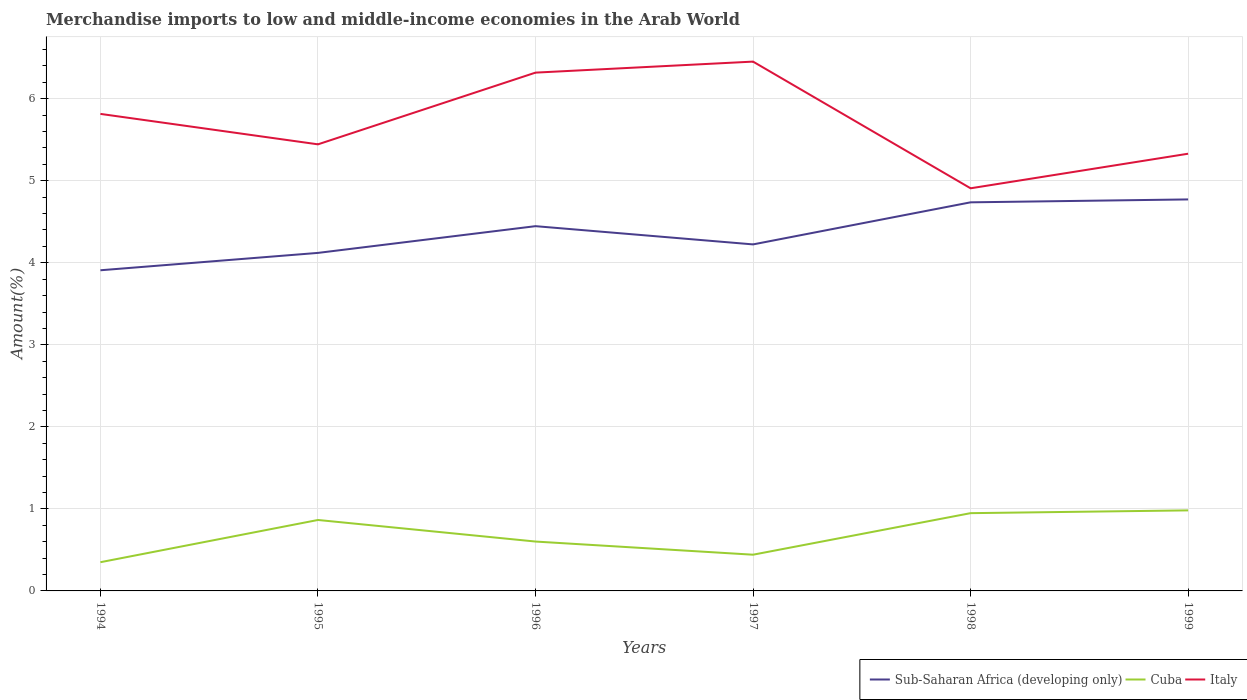How many different coloured lines are there?
Your answer should be very brief. 3. Is the number of lines equal to the number of legend labels?
Provide a short and direct response. Yes. Across all years, what is the maximum percentage of amount earned from merchandise imports in Italy?
Your answer should be very brief. 4.91. What is the total percentage of amount earned from merchandise imports in Italy in the graph?
Provide a short and direct response. -0.64. What is the difference between the highest and the second highest percentage of amount earned from merchandise imports in Sub-Saharan Africa (developing only)?
Your answer should be compact. 0.86. How many years are there in the graph?
Ensure brevity in your answer.  6. What is the difference between two consecutive major ticks on the Y-axis?
Offer a very short reply. 1. Are the values on the major ticks of Y-axis written in scientific E-notation?
Keep it short and to the point. No. Does the graph contain any zero values?
Provide a short and direct response. No. Where does the legend appear in the graph?
Provide a short and direct response. Bottom right. How many legend labels are there?
Your answer should be very brief. 3. How are the legend labels stacked?
Ensure brevity in your answer.  Horizontal. What is the title of the graph?
Ensure brevity in your answer.  Merchandise imports to low and middle-income economies in the Arab World. What is the label or title of the Y-axis?
Your answer should be very brief. Amount(%). What is the Amount(%) of Sub-Saharan Africa (developing only) in 1994?
Give a very brief answer. 3.91. What is the Amount(%) of Cuba in 1994?
Your answer should be very brief. 0.35. What is the Amount(%) in Italy in 1994?
Make the answer very short. 5.82. What is the Amount(%) of Sub-Saharan Africa (developing only) in 1995?
Your answer should be compact. 4.12. What is the Amount(%) of Cuba in 1995?
Make the answer very short. 0.86. What is the Amount(%) in Italy in 1995?
Offer a terse response. 5.44. What is the Amount(%) in Sub-Saharan Africa (developing only) in 1996?
Offer a very short reply. 4.45. What is the Amount(%) of Cuba in 1996?
Provide a succinct answer. 0.6. What is the Amount(%) in Italy in 1996?
Give a very brief answer. 6.32. What is the Amount(%) in Sub-Saharan Africa (developing only) in 1997?
Provide a succinct answer. 4.22. What is the Amount(%) of Cuba in 1997?
Your answer should be very brief. 0.44. What is the Amount(%) in Italy in 1997?
Give a very brief answer. 6.45. What is the Amount(%) in Sub-Saharan Africa (developing only) in 1998?
Your answer should be compact. 4.74. What is the Amount(%) of Cuba in 1998?
Make the answer very short. 0.95. What is the Amount(%) in Italy in 1998?
Offer a very short reply. 4.91. What is the Amount(%) in Sub-Saharan Africa (developing only) in 1999?
Keep it short and to the point. 4.77. What is the Amount(%) of Cuba in 1999?
Give a very brief answer. 0.98. What is the Amount(%) of Italy in 1999?
Provide a short and direct response. 5.33. Across all years, what is the maximum Amount(%) in Sub-Saharan Africa (developing only)?
Ensure brevity in your answer.  4.77. Across all years, what is the maximum Amount(%) of Cuba?
Your answer should be compact. 0.98. Across all years, what is the maximum Amount(%) in Italy?
Your answer should be compact. 6.45. Across all years, what is the minimum Amount(%) of Sub-Saharan Africa (developing only)?
Make the answer very short. 3.91. Across all years, what is the minimum Amount(%) in Cuba?
Your answer should be very brief. 0.35. Across all years, what is the minimum Amount(%) in Italy?
Provide a succinct answer. 4.91. What is the total Amount(%) in Sub-Saharan Africa (developing only) in the graph?
Your response must be concise. 26.21. What is the total Amount(%) in Cuba in the graph?
Your answer should be compact. 4.19. What is the total Amount(%) in Italy in the graph?
Your response must be concise. 34.27. What is the difference between the Amount(%) of Sub-Saharan Africa (developing only) in 1994 and that in 1995?
Give a very brief answer. -0.21. What is the difference between the Amount(%) in Cuba in 1994 and that in 1995?
Your response must be concise. -0.51. What is the difference between the Amount(%) of Italy in 1994 and that in 1995?
Your response must be concise. 0.37. What is the difference between the Amount(%) of Sub-Saharan Africa (developing only) in 1994 and that in 1996?
Your answer should be very brief. -0.54. What is the difference between the Amount(%) in Cuba in 1994 and that in 1996?
Give a very brief answer. -0.25. What is the difference between the Amount(%) of Italy in 1994 and that in 1996?
Ensure brevity in your answer.  -0.5. What is the difference between the Amount(%) of Sub-Saharan Africa (developing only) in 1994 and that in 1997?
Offer a very short reply. -0.32. What is the difference between the Amount(%) in Cuba in 1994 and that in 1997?
Offer a very short reply. -0.09. What is the difference between the Amount(%) in Italy in 1994 and that in 1997?
Keep it short and to the point. -0.64. What is the difference between the Amount(%) in Sub-Saharan Africa (developing only) in 1994 and that in 1998?
Give a very brief answer. -0.83. What is the difference between the Amount(%) in Cuba in 1994 and that in 1998?
Offer a very short reply. -0.6. What is the difference between the Amount(%) of Italy in 1994 and that in 1998?
Your answer should be compact. 0.91. What is the difference between the Amount(%) in Sub-Saharan Africa (developing only) in 1994 and that in 1999?
Keep it short and to the point. -0.86. What is the difference between the Amount(%) in Cuba in 1994 and that in 1999?
Make the answer very short. -0.63. What is the difference between the Amount(%) in Italy in 1994 and that in 1999?
Offer a terse response. 0.49. What is the difference between the Amount(%) in Sub-Saharan Africa (developing only) in 1995 and that in 1996?
Provide a short and direct response. -0.33. What is the difference between the Amount(%) of Cuba in 1995 and that in 1996?
Make the answer very short. 0.26. What is the difference between the Amount(%) of Italy in 1995 and that in 1996?
Provide a short and direct response. -0.87. What is the difference between the Amount(%) in Sub-Saharan Africa (developing only) in 1995 and that in 1997?
Make the answer very short. -0.1. What is the difference between the Amount(%) in Cuba in 1995 and that in 1997?
Make the answer very short. 0.42. What is the difference between the Amount(%) of Italy in 1995 and that in 1997?
Give a very brief answer. -1.01. What is the difference between the Amount(%) in Sub-Saharan Africa (developing only) in 1995 and that in 1998?
Ensure brevity in your answer.  -0.62. What is the difference between the Amount(%) in Cuba in 1995 and that in 1998?
Your answer should be very brief. -0.08. What is the difference between the Amount(%) in Italy in 1995 and that in 1998?
Your answer should be very brief. 0.54. What is the difference between the Amount(%) of Sub-Saharan Africa (developing only) in 1995 and that in 1999?
Offer a very short reply. -0.65. What is the difference between the Amount(%) in Cuba in 1995 and that in 1999?
Your response must be concise. -0.12. What is the difference between the Amount(%) of Italy in 1995 and that in 1999?
Offer a terse response. 0.11. What is the difference between the Amount(%) in Sub-Saharan Africa (developing only) in 1996 and that in 1997?
Provide a succinct answer. 0.22. What is the difference between the Amount(%) in Cuba in 1996 and that in 1997?
Offer a very short reply. 0.16. What is the difference between the Amount(%) in Italy in 1996 and that in 1997?
Your answer should be very brief. -0.13. What is the difference between the Amount(%) in Sub-Saharan Africa (developing only) in 1996 and that in 1998?
Make the answer very short. -0.29. What is the difference between the Amount(%) in Cuba in 1996 and that in 1998?
Give a very brief answer. -0.35. What is the difference between the Amount(%) in Italy in 1996 and that in 1998?
Keep it short and to the point. 1.41. What is the difference between the Amount(%) in Sub-Saharan Africa (developing only) in 1996 and that in 1999?
Your answer should be compact. -0.33. What is the difference between the Amount(%) of Cuba in 1996 and that in 1999?
Your answer should be very brief. -0.38. What is the difference between the Amount(%) in Sub-Saharan Africa (developing only) in 1997 and that in 1998?
Provide a short and direct response. -0.51. What is the difference between the Amount(%) in Cuba in 1997 and that in 1998?
Provide a succinct answer. -0.51. What is the difference between the Amount(%) of Italy in 1997 and that in 1998?
Keep it short and to the point. 1.54. What is the difference between the Amount(%) of Sub-Saharan Africa (developing only) in 1997 and that in 1999?
Your answer should be very brief. -0.55. What is the difference between the Amount(%) in Cuba in 1997 and that in 1999?
Offer a terse response. -0.54. What is the difference between the Amount(%) of Italy in 1997 and that in 1999?
Provide a short and direct response. 1.12. What is the difference between the Amount(%) of Sub-Saharan Africa (developing only) in 1998 and that in 1999?
Keep it short and to the point. -0.04. What is the difference between the Amount(%) of Cuba in 1998 and that in 1999?
Provide a short and direct response. -0.03. What is the difference between the Amount(%) in Italy in 1998 and that in 1999?
Your answer should be very brief. -0.42. What is the difference between the Amount(%) in Sub-Saharan Africa (developing only) in 1994 and the Amount(%) in Cuba in 1995?
Keep it short and to the point. 3.04. What is the difference between the Amount(%) in Sub-Saharan Africa (developing only) in 1994 and the Amount(%) in Italy in 1995?
Your answer should be very brief. -1.54. What is the difference between the Amount(%) of Cuba in 1994 and the Amount(%) of Italy in 1995?
Offer a very short reply. -5.09. What is the difference between the Amount(%) in Sub-Saharan Africa (developing only) in 1994 and the Amount(%) in Cuba in 1996?
Offer a terse response. 3.31. What is the difference between the Amount(%) in Sub-Saharan Africa (developing only) in 1994 and the Amount(%) in Italy in 1996?
Provide a succinct answer. -2.41. What is the difference between the Amount(%) in Cuba in 1994 and the Amount(%) in Italy in 1996?
Provide a succinct answer. -5.97. What is the difference between the Amount(%) of Sub-Saharan Africa (developing only) in 1994 and the Amount(%) of Cuba in 1997?
Provide a short and direct response. 3.47. What is the difference between the Amount(%) in Sub-Saharan Africa (developing only) in 1994 and the Amount(%) in Italy in 1997?
Give a very brief answer. -2.54. What is the difference between the Amount(%) of Cuba in 1994 and the Amount(%) of Italy in 1997?
Ensure brevity in your answer.  -6.1. What is the difference between the Amount(%) of Sub-Saharan Africa (developing only) in 1994 and the Amount(%) of Cuba in 1998?
Your answer should be compact. 2.96. What is the difference between the Amount(%) in Sub-Saharan Africa (developing only) in 1994 and the Amount(%) in Italy in 1998?
Offer a very short reply. -1. What is the difference between the Amount(%) in Cuba in 1994 and the Amount(%) in Italy in 1998?
Ensure brevity in your answer.  -4.56. What is the difference between the Amount(%) of Sub-Saharan Africa (developing only) in 1994 and the Amount(%) of Cuba in 1999?
Ensure brevity in your answer.  2.93. What is the difference between the Amount(%) of Sub-Saharan Africa (developing only) in 1994 and the Amount(%) of Italy in 1999?
Offer a terse response. -1.42. What is the difference between the Amount(%) in Cuba in 1994 and the Amount(%) in Italy in 1999?
Provide a succinct answer. -4.98. What is the difference between the Amount(%) of Sub-Saharan Africa (developing only) in 1995 and the Amount(%) of Cuba in 1996?
Your answer should be very brief. 3.52. What is the difference between the Amount(%) in Sub-Saharan Africa (developing only) in 1995 and the Amount(%) in Italy in 1996?
Your response must be concise. -2.2. What is the difference between the Amount(%) in Cuba in 1995 and the Amount(%) in Italy in 1996?
Your response must be concise. -5.45. What is the difference between the Amount(%) in Sub-Saharan Africa (developing only) in 1995 and the Amount(%) in Cuba in 1997?
Your answer should be very brief. 3.68. What is the difference between the Amount(%) in Sub-Saharan Africa (developing only) in 1995 and the Amount(%) in Italy in 1997?
Provide a short and direct response. -2.33. What is the difference between the Amount(%) in Cuba in 1995 and the Amount(%) in Italy in 1997?
Offer a terse response. -5.59. What is the difference between the Amount(%) of Sub-Saharan Africa (developing only) in 1995 and the Amount(%) of Cuba in 1998?
Provide a succinct answer. 3.17. What is the difference between the Amount(%) of Sub-Saharan Africa (developing only) in 1995 and the Amount(%) of Italy in 1998?
Give a very brief answer. -0.79. What is the difference between the Amount(%) in Cuba in 1995 and the Amount(%) in Italy in 1998?
Your answer should be very brief. -4.04. What is the difference between the Amount(%) of Sub-Saharan Africa (developing only) in 1995 and the Amount(%) of Cuba in 1999?
Provide a succinct answer. 3.14. What is the difference between the Amount(%) of Sub-Saharan Africa (developing only) in 1995 and the Amount(%) of Italy in 1999?
Keep it short and to the point. -1.21. What is the difference between the Amount(%) of Cuba in 1995 and the Amount(%) of Italy in 1999?
Ensure brevity in your answer.  -4.46. What is the difference between the Amount(%) of Sub-Saharan Africa (developing only) in 1996 and the Amount(%) of Cuba in 1997?
Your answer should be compact. 4.01. What is the difference between the Amount(%) in Sub-Saharan Africa (developing only) in 1996 and the Amount(%) in Italy in 1997?
Offer a very short reply. -2.01. What is the difference between the Amount(%) in Cuba in 1996 and the Amount(%) in Italy in 1997?
Offer a terse response. -5.85. What is the difference between the Amount(%) in Sub-Saharan Africa (developing only) in 1996 and the Amount(%) in Cuba in 1998?
Offer a terse response. 3.5. What is the difference between the Amount(%) of Sub-Saharan Africa (developing only) in 1996 and the Amount(%) of Italy in 1998?
Keep it short and to the point. -0.46. What is the difference between the Amount(%) of Cuba in 1996 and the Amount(%) of Italy in 1998?
Offer a very short reply. -4.31. What is the difference between the Amount(%) in Sub-Saharan Africa (developing only) in 1996 and the Amount(%) in Cuba in 1999?
Provide a short and direct response. 3.46. What is the difference between the Amount(%) of Sub-Saharan Africa (developing only) in 1996 and the Amount(%) of Italy in 1999?
Offer a terse response. -0.88. What is the difference between the Amount(%) in Cuba in 1996 and the Amount(%) in Italy in 1999?
Keep it short and to the point. -4.73. What is the difference between the Amount(%) in Sub-Saharan Africa (developing only) in 1997 and the Amount(%) in Cuba in 1998?
Your response must be concise. 3.28. What is the difference between the Amount(%) of Sub-Saharan Africa (developing only) in 1997 and the Amount(%) of Italy in 1998?
Ensure brevity in your answer.  -0.68. What is the difference between the Amount(%) in Cuba in 1997 and the Amount(%) in Italy in 1998?
Your response must be concise. -4.47. What is the difference between the Amount(%) in Sub-Saharan Africa (developing only) in 1997 and the Amount(%) in Cuba in 1999?
Keep it short and to the point. 3.24. What is the difference between the Amount(%) of Sub-Saharan Africa (developing only) in 1997 and the Amount(%) of Italy in 1999?
Make the answer very short. -1.11. What is the difference between the Amount(%) of Cuba in 1997 and the Amount(%) of Italy in 1999?
Your response must be concise. -4.89. What is the difference between the Amount(%) of Sub-Saharan Africa (developing only) in 1998 and the Amount(%) of Cuba in 1999?
Your response must be concise. 3.76. What is the difference between the Amount(%) of Sub-Saharan Africa (developing only) in 1998 and the Amount(%) of Italy in 1999?
Keep it short and to the point. -0.59. What is the difference between the Amount(%) in Cuba in 1998 and the Amount(%) in Italy in 1999?
Provide a short and direct response. -4.38. What is the average Amount(%) of Sub-Saharan Africa (developing only) per year?
Your answer should be very brief. 4.37. What is the average Amount(%) in Cuba per year?
Keep it short and to the point. 0.7. What is the average Amount(%) in Italy per year?
Offer a very short reply. 5.71. In the year 1994, what is the difference between the Amount(%) of Sub-Saharan Africa (developing only) and Amount(%) of Cuba?
Ensure brevity in your answer.  3.56. In the year 1994, what is the difference between the Amount(%) of Sub-Saharan Africa (developing only) and Amount(%) of Italy?
Provide a succinct answer. -1.91. In the year 1994, what is the difference between the Amount(%) in Cuba and Amount(%) in Italy?
Provide a short and direct response. -5.47. In the year 1995, what is the difference between the Amount(%) in Sub-Saharan Africa (developing only) and Amount(%) in Cuba?
Provide a succinct answer. 3.26. In the year 1995, what is the difference between the Amount(%) of Sub-Saharan Africa (developing only) and Amount(%) of Italy?
Make the answer very short. -1.32. In the year 1995, what is the difference between the Amount(%) of Cuba and Amount(%) of Italy?
Your answer should be compact. -4.58. In the year 1996, what is the difference between the Amount(%) of Sub-Saharan Africa (developing only) and Amount(%) of Cuba?
Give a very brief answer. 3.84. In the year 1996, what is the difference between the Amount(%) of Sub-Saharan Africa (developing only) and Amount(%) of Italy?
Make the answer very short. -1.87. In the year 1996, what is the difference between the Amount(%) of Cuba and Amount(%) of Italy?
Your answer should be very brief. -5.72. In the year 1997, what is the difference between the Amount(%) in Sub-Saharan Africa (developing only) and Amount(%) in Cuba?
Your answer should be very brief. 3.78. In the year 1997, what is the difference between the Amount(%) of Sub-Saharan Africa (developing only) and Amount(%) of Italy?
Provide a succinct answer. -2.23. In the year 1997, what is the difference between the Amount(%) of Cuba and Amount(%) of Italy?
Ensure brevity in your answer.  -6.01. In the year 1998, what is the difference between the Amount(%) of Sub-Saharan Africa (developing only) and Amount(%) of Cuba?
Your answer should be compact. 3.79. In the year 1998, what is the difference between the Amount(%) of Sub-Saharan Africa (developing only) and Amount(%) of Italy?
Offer a very short reply. -0.17. In the year 1998, what is the difference between the Amount(%) in Cuba and Amount(%) in Italy?
Your response must be concise. -3.96. In the year 1999, what is the difference between the Amount(%) of Sub-Saharan Africa (developing only) and Amount(%) of Cuba?
Your answer should be very brief. 3.79. In the year 1999, what is the difference between the Amount(%) in Sub-Saharan Africa (developing only) and Amount(%) in Italy?
Provide a short and direct response. -0.56. In the year 1999, what is the difference between the Amount(%) of Cuba and Amount(%) of Italy?
Your answer should be very brief. -4.35. What is the ratio of the Amount(%) of Sub-Saharan Africa (developing only) in 1994 to that in 1995?
Your answer should be compact. 0.95. What is the ratio of the Amount(%) in Cuba in 1994 to that in 1995?
Offer a terse response. 0.4. What is the ratio of the Amount(%) in Italy in 1994 to that in 1995?
Provide a succinct answer. 1.07. What is the ratio of the Amount(%) of Sub-Saharan Africa (developing only) in 1994 to that in 1996?
Make the answer very short. 0.88. What is the ratio of the Amount(%) of Cuba in 1994 to that in 1996?
Ensure brevity in your answer.  0.58. What is the ratio of the Amount(%) in Italy in 1994 to that in 1996?
Your response must be concise. 0.92. What is the ratio of the Amount(%) of Sub-Saharan Africa (developing only) in 1994 to that in 1997?
Your answer should be compact. 0.93. What is the ratio of the Amount(%) in Cuba in 1994 to that in 1997?
Provide a succinct answer. 0.79. What is the ratio of the Amount(%) of Italy in 1994 to that in 1997?
Keep it short and to the point. 0.9. What is the ratio of the Amount(%) in Sub-Saharan Africa (developing only) in 1994 to that in 1998?
Give a very brief answer. 0.83. What is the ratio of the Amount(%) of Cuba in 1994 to that in 1998?
Offer a terse response. 0.37. What is the ratio of the Amount(%) in Italy in 1994 to that in 1998?
Keep it short and to the point. 1.18. What is the ratio of the Amount(%) of Sub-Saharan Africa (developing only) in 1994 to that in 1999?
Give a very brief answer. 0.82. What is the ratio of the Amount(%) of Cuba in 1994 to that in 1999?
Your answer should be compact. 0.36. What is the ratio of the Amount(%) in Italy in 1994 to that in 1999?
Provide a succinct answer. 1.09. What is the ratio of the Amount(%) of Sub-Saharan Africa (developing only) in 1995 to that in 1996?
Ensure brevity in your answer.  0.93. What is the ratio of the Amount(%) in Cuba in 1995 to that in 1996?
Make the answer very short. 1.44. What is the ratio of the Amount(%) of Italy in 1995 to that in 1996?
Keep it short and to the point. 0.86. What is the ratio of the Amount(%) of Sub-Saharan Africa (developing only) in 1995 to that in 1997?
Ensure brevity in your answer.  0.98. What is the ratio of the Amount(%) of Cuba in 1995 to that in 1997?
Offer a very short reply. 1.96. What is the ratio of the Amount(%) in Italy in 1995 to that in 1997?
Your answer should be very brief. 0.84. What is the ratio of the Amount(%) in Sub-Saharan Africa (developing only) in 1995 to that in 1998?
Your answer should be compact. 0.87. What is the ratio of the Amount(%) of Cuba in 1995 to that in 1998?
Your answer should be very brief. 0.91. What is the ratio of the Amount(%) in Italy in 1995 to that in 1998?
Offer a terse response. 1.11. What is the ratio of the Amount(%) of Sub-Saharan Africa (developing only) in 1995 to that in 1999?
Your response must be concise. 0.86. What is the ratio of the Amount(%) of Cuba in 1995 to that in 1999?
Your answer should be very brief. 0.88. What is the ratio of the Amount(%) in Italy in 1995 to that in 1999?
Your answer should be compact. 1.02. What is the ratio of the Amount(%) of Sub-Saharan Africa (developing only) in 1996 to that in 1997?
Your response must be concise. 1.05. What is the ratio of the Amount(%) of Cuba in 1996 to that in 1997?
Make the answer very short. 1.36. What is the ratio of the Amount(%) of Italy in 1996 to that in 1997?
Make the answer very short. 0.98. What is the ratio of the Amount(%) in Sub-Saharan Africa (developing only) in 1996 to that in 1998?
Ensure brevity in your answer.  0.94. What is the ratio of the Amount(%) in Cuba in 1996 to that in 1998?
Make the answer very short. 0.64. What is the ratio of the Amount(%) in Italy in 1996 to that in 1998?
Your answer should be very brief. 1.29. What is the ratio of the Amount(%) of Sub-Saharan Africa (developing only) in 1996 to that in 1999?
Ensure brevity in your answer.  0.93. What is the ratio of the Amount(%) in Cuba in 1996 to that in 1999?
Ensure brevity in your answer.  0.61. What is the ratio of the Amount(%) of Italy in 1996 to that in 1999?
Provide a short and direct response. 1.19. What is the ratio of the Amount(%) in Sub-Saharan Africa (developing only) in 1997 to that in 1998?
Offer a very short reply. 0.89. What is the ratio of the Amount(%) in Cuba in 1997 to that in 1998?
Offer a terse response. 0.47. What is the ratio of the Amount(%) of Italy in 1997 to that in 1998?
Your response must be concise. 1.31. What is the ratio of the Amount(%) in Sub-Saharan Africa (developing only) in 1997 to that in 1999?
Offer a very short reply. 0.89. What is the ratio of the Amount(%) of Cuba in 1997 to that in 1999?
Offer a very short reply. 0.45. What is the ratio of the Amount(%) of Italy in 1997 to that in 1999?
Your answer should be very brief. 1.21. What is the ratio of the Amount(%) of Sub-Saharan Africa (developing only) in 1998 to that in 1999?
Offer a very short reply. 0.99. What is the ratio of the Amount(%) of Cuba in 1998 to that in 1999?
Provide a succinct answer. 0.97. What is the ratio of the Amount(%) in Italy in 1998 to that in 1999?
Offer a very short reply. 0.92. What is the difference between the highest and the second highest Amount(%) of Sub-Saharan Africa (developing only)?
Your response must be concise. 0.04. What is the difference between the highest and the second highest Amount(%) of Cuba?
Offer a terse response. 0.03. What is the difference between the highest and the second highest Amount(%) in Italy?
Your answer should be compact. 0.13. What is the difference between the highest and the lowest Amount(%) of Sub-Saharan Africa (developing only)?
Your response must be concise. 0.86. What is the difference between the highest and the lowest Amount(%) in Cuba?
Provide a short and direct response. 0.63. What is the difference between the highest and the lowest Amount(%) in Italy?
Give a very brief answer. 1.54. 